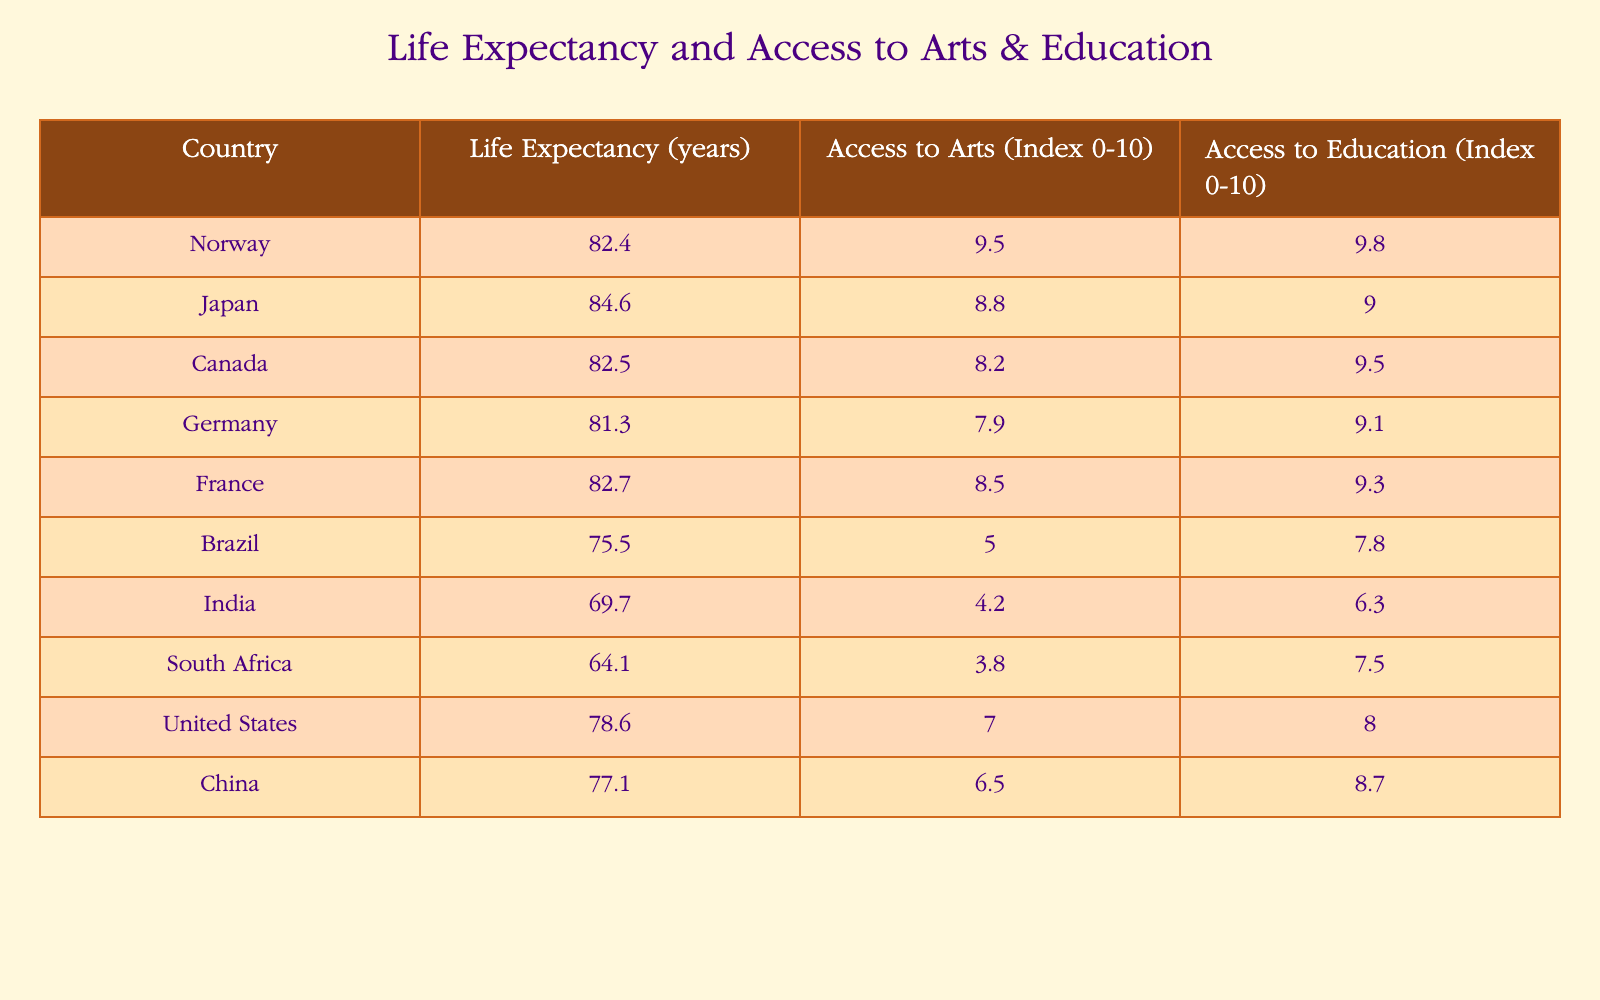What is the life expectancy of Japan? The table directly shows that Japan has a life expectancy of 84.6 years.
Answer: 84.6 years Which country has the highest access to arts index? According to the table, Norway has the highest access to arts index at 9.5.
Answer: Norway What is the average life expectancy of the countries listed in the table? To find the average life expectancy, sum the life expectancies: (82.4 + 84.6 + 82.5 + 81.3 + 82.7 + 75.5 + 69.7 + 64.1 + 78.6 + 77.1) =  817.5. There are 10 countries, so the average is 817.5/10 = 81.75 years.
Answer: 81.75 years Is it true that Brazil has a higher access to education index than South Africa? The table indicates that Brazil has an access to education index of 7.8, while South Africa has an index of 7.5. Therefore, the statement is true.
Answer: Yes Which country has a lower access to arts index, India or China? India has an access to arts index of 4.2 and China has an access to arts index of 6.5. Since 4.2 is less than 6.5, India has a lower index.
Answer: India What is the difference between the access to education indices of Canada and the United States? Canada has an access to education index of 9.5 and the United States has an index of 8.0. The difference is calculated as 9.5 - 8.0 = 1.5.
Answer: 1.5 Which country ranks second in life expectancy and what is its access to arts index? The second highest life expectancy is held by Japan at 84.6 years. Its access to arts index is 8.8.
Answer: Japan, 8.8 Are there more countries with an access to arts index above 7 or below 7? By analyzing the table, Norway, Japan, Canada, Germany, France, and the United States all have indices above 7, totaling 6 countries. Brazil, India, and South Africa have indices below 7, totaling 4 countries. Therefore, there are more countries above 7.
Answer: Above 7 What is the overall trend in life expectancy relative to access to arts and education across the countries listed? The data suggests that countries with higher life expectancy tend to also have higher indices for access to arts and education, illustrating a potential correlation between these factors. For example, Japan, Norway, and Canada all have high life expectancies and arts/access to education indices.
Answer: Positive correlation 